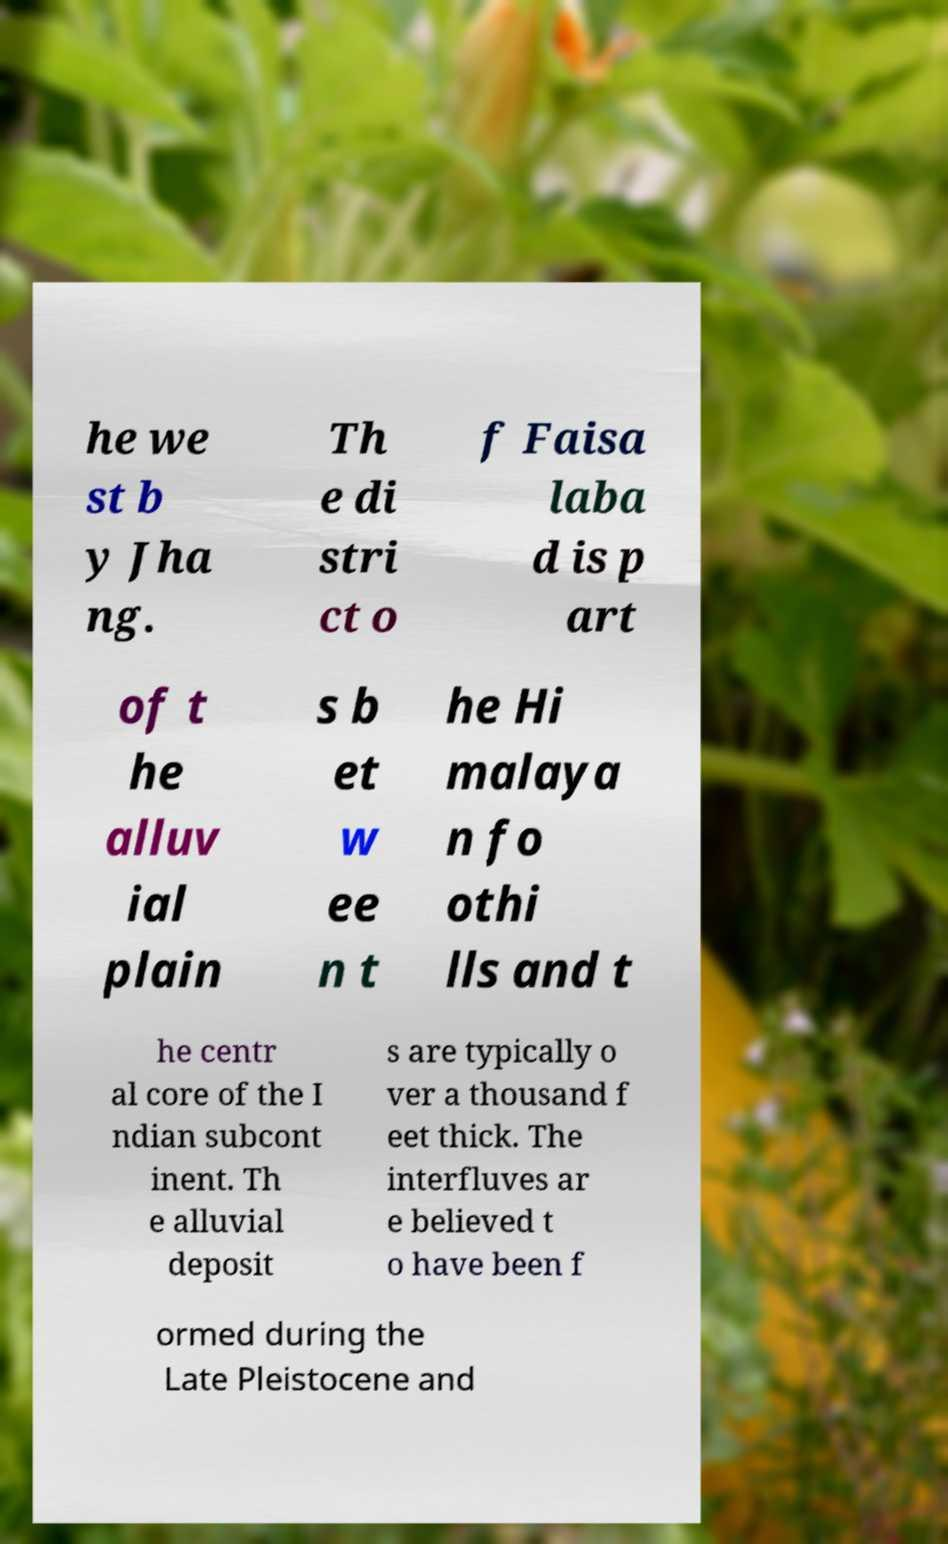Please read and relay the text visible in this image. What does it say? he we st b y Jha ng. Th e di stri ct o f Faisa laba d is p art of t he alluv ial plain s b et w ee n t he Hi malaya n fo othi lls and t he centr al core of the I ndian subcont inent. Th e alluvial deposit s are typically o ver a thousand f eet thick. The interfluves ar e believed t o have been f ormed during the Late Pleistocene and 